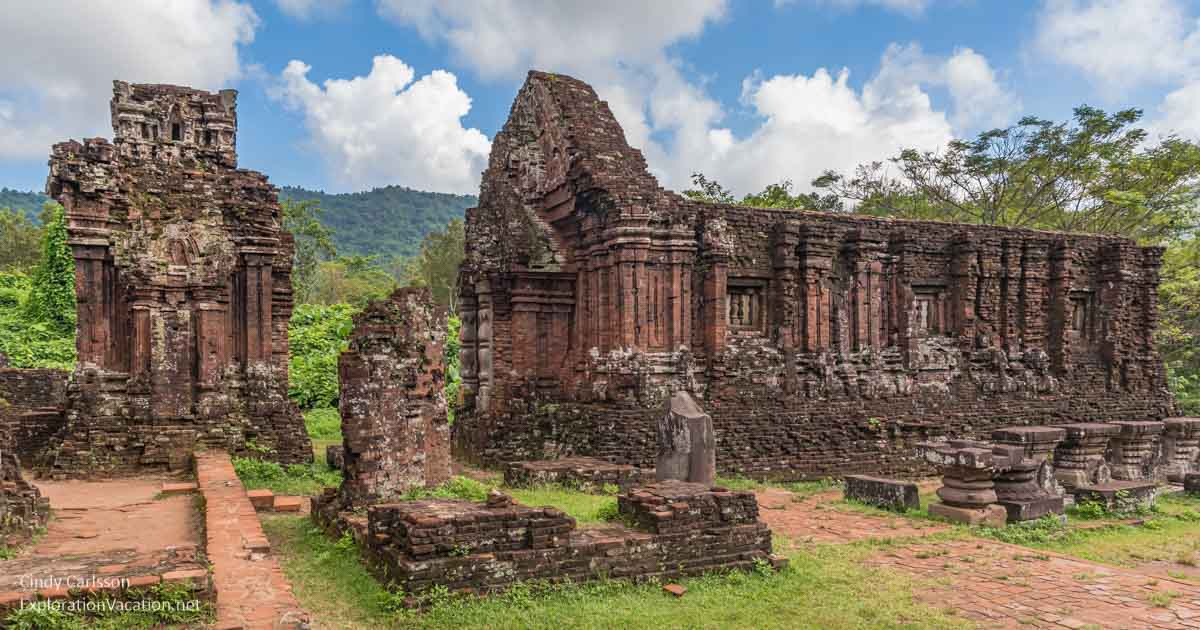Imagine the temple complex at the height of its use. What might it have looked like? In its prime, the My Son temple complex would have been a bustling hub of religious activity and architectural splendor. The temples, adorned with intricate stone carvings and vibrant colors, would have stood tall and majestic, their spires reaching towards the sky. Priests and devotees would have thronged the temples, performing rituals and ceremonies amidst the aromatic waft of incense and the rhythmic chants of hymns. Surrounding the temples, verdant gardens and courtyards would have been meticulously maintained, offering a serene environment for contemplation and worship. The sight would have been both awe-inspiring and tranquil, a true epitome of ancient grandeur and spirituality. If this temple complex could speak, what stories would it tell? If the My Son temple complex could speak, it would narrate tales of its glorious past, reflecting centuries of devotion, power, and artistry. It would recount the grandeur of the Champa kings who commissioned these temples, the skilled artisans who painstakingly carved the intricate reliefs, and the priests who performed sacred rituals in its sanctums. It would tell of the times when the temples echoed with the hymns and prayers of devout worshippers and witnessed grand religious ceremonies celebrating the divine. It would also speak of the invasions and conflicts that led to its partial destruction and the relentless passage of time that weathered its structures. Despite all, it stands resilient, a silent storyteller of an ancient civilization's rich heritage and enduring spirit. 